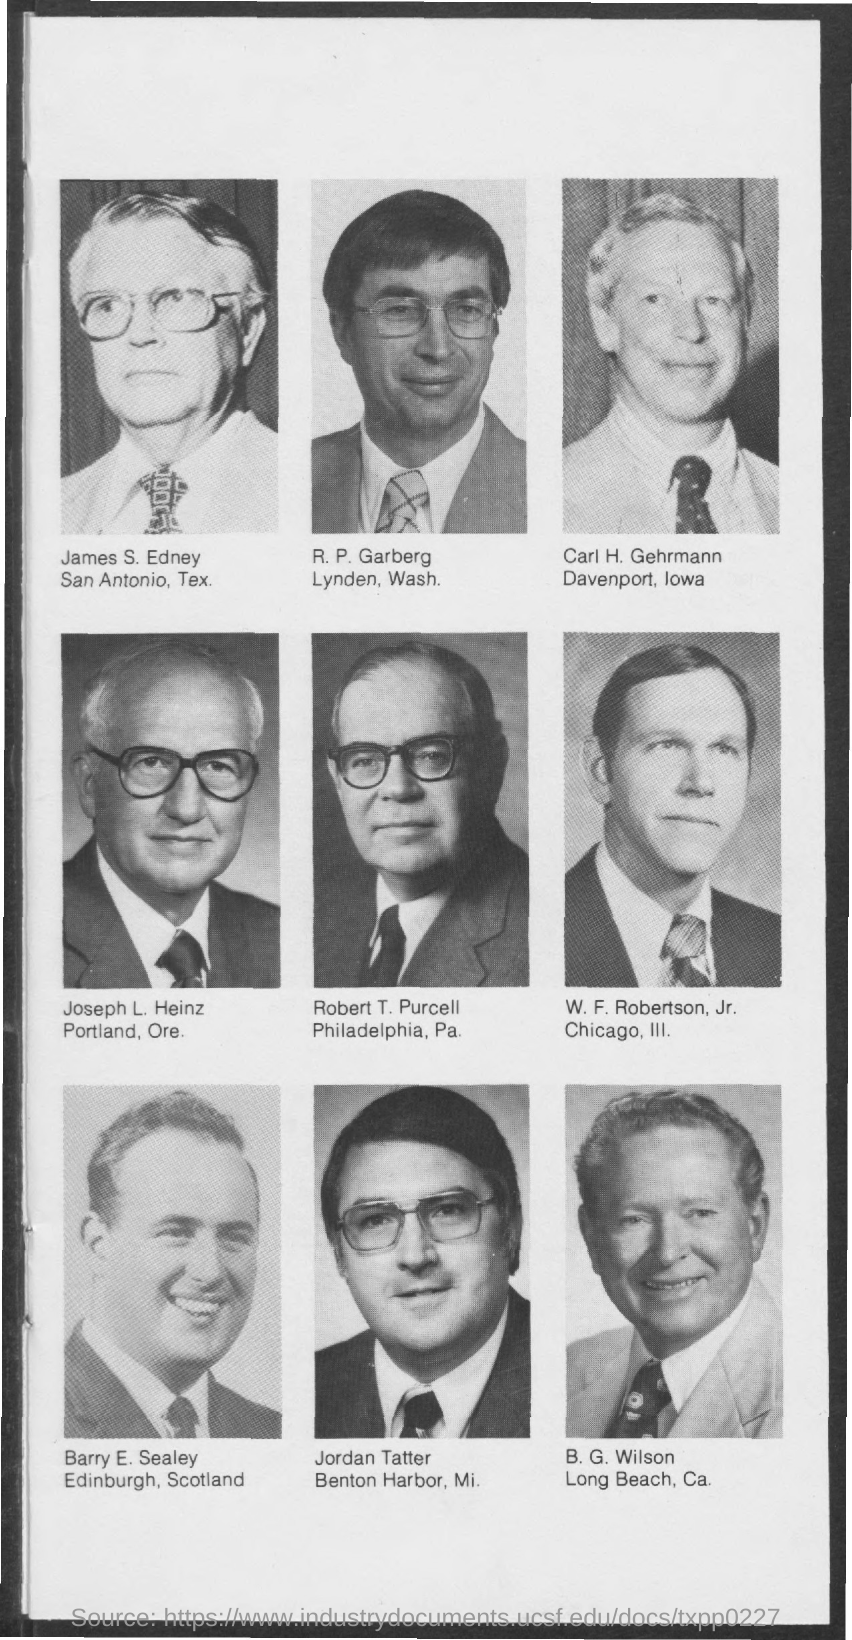Mention a couple of crucial points in this snapshot. Barry E. Sealey is originally from Edinburgh, Scotland. 